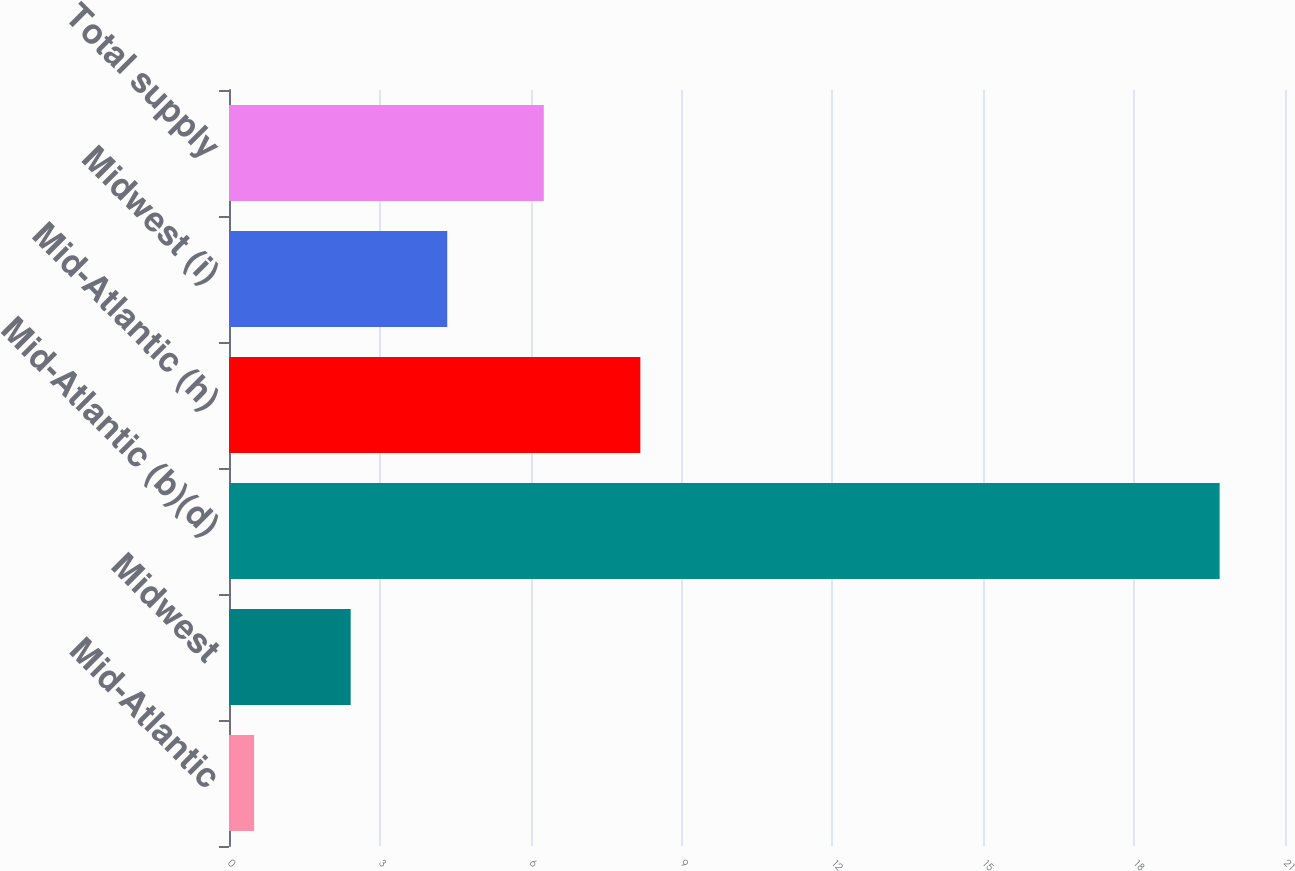Convert chart to OTSL. <chart><loc_0><loc_0><loc_500><loc_500><bar_chart><fcel>Mid-Atlantic<fcel>Midwest<fcel>Mid-Atlantic (b)(d)<fcel>Mid-Atlantic (h)<fcel>Midwest (i)<fcel>Total supply<nl><fcel>0.5<fcel>2.42<fcel>19.7<fcel>8.18<fcel>4.34<fcel>6.26<nl></chart> 